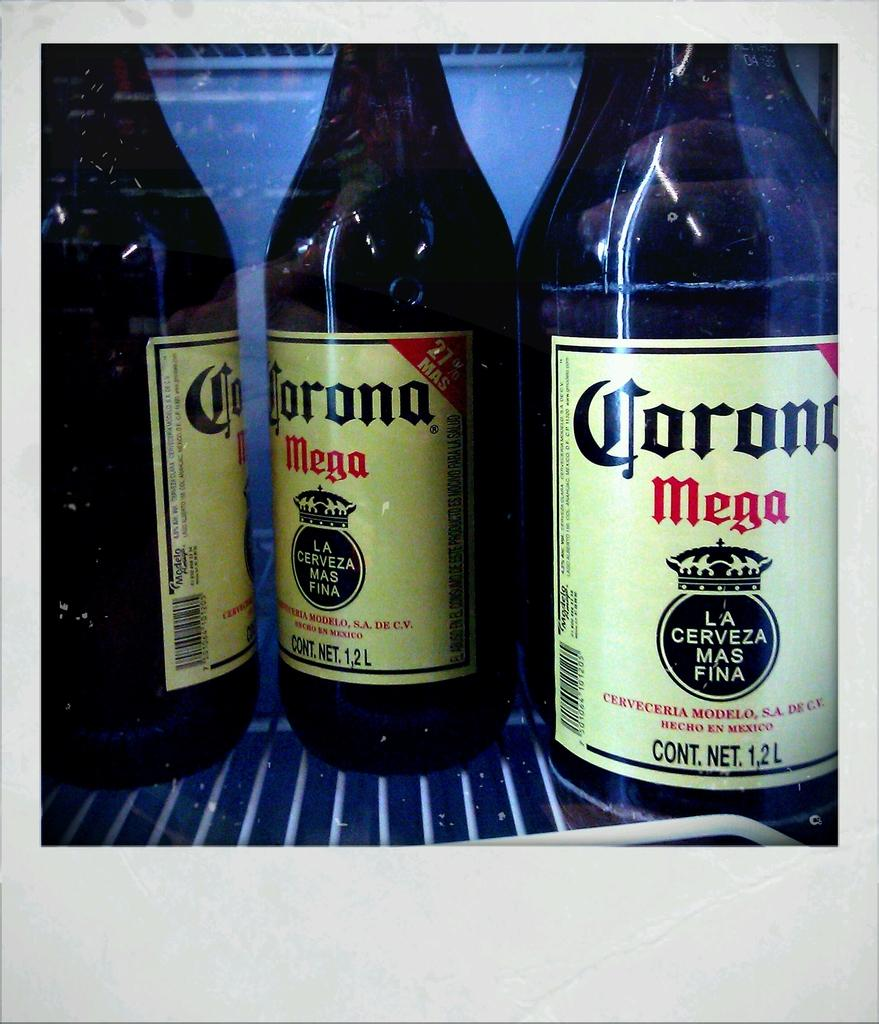<image>
Provide a brief description of the given image. several bottles of corona mega on a wire shelf 